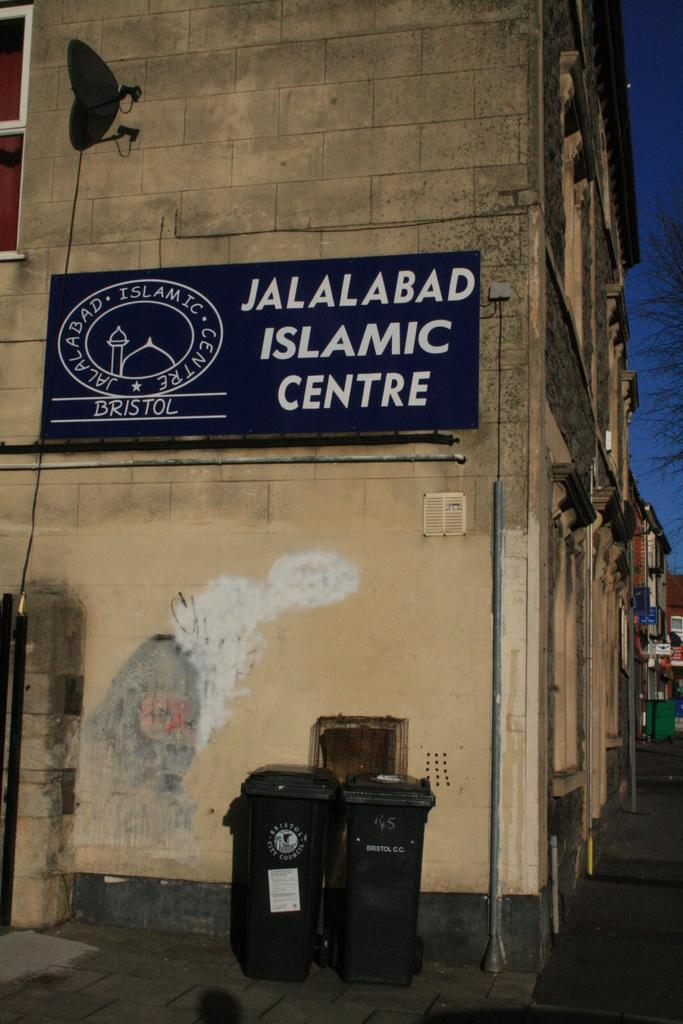<image>
Relay a brief, clear account of the picture shown. A sign for the Jalalabad Islamic Centre on the outside of an older building. 